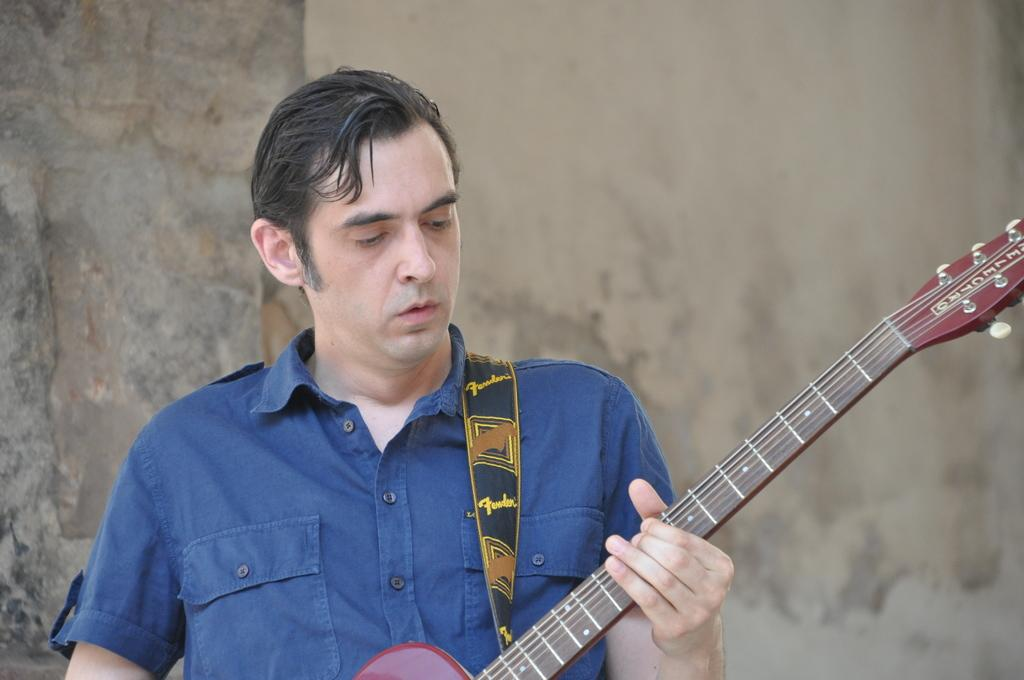Who is the main subject in the image? There is a man in the image. What is the man wearing? The man is wearing a blue shirt. What is the man holding in the image? The man is holding a guitar. What is the man doing with the guitar? The man is playing the guitar. What can be seen in the background of the image? There is a wall in the background of the image. What type of jewel is the man wearing on his neck in the image? There is no jewel visible on the man's neck in the image. How does the committee contribute to the man's guitar playing in the image? There is no committee present in the image, and therefore it cannot contribute to the man's guitar playing. 